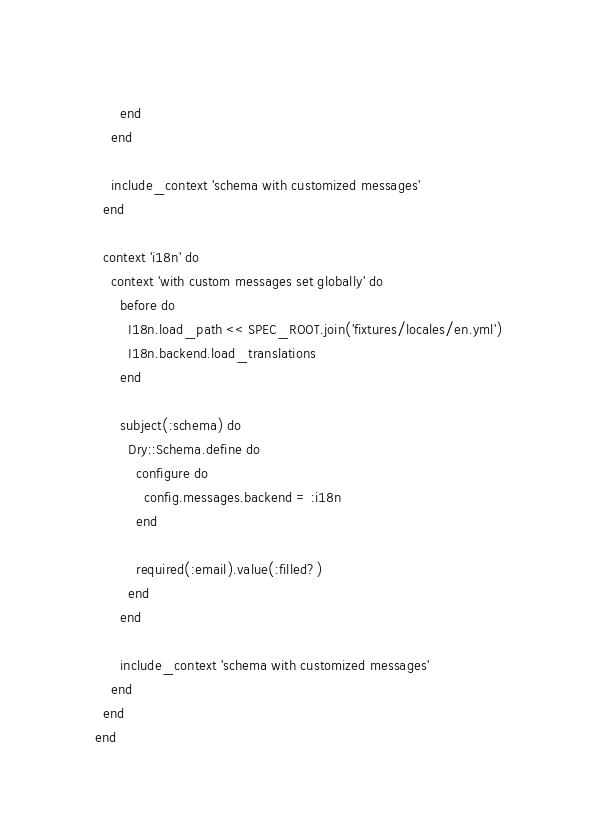<code> <loc_0><loc_0><loc_500><loc_500><_Ruby_>      end
    end

    include_context 'schema with customized messages'
  end

  context 'i18n' do
    context 'with custom messages set globally' do
      before do
        I18n.load_path << SPEC_ROOT.join('fixtures/locales/en.yml')
        I18n.backend.load_translations
      end

      subject(:schema) do
        Dry::Schema.define do
          configure do
            config.messages.backend = :i18n
          end

          required(:email).value(:filled?)
        end
      end

      include_context 'schema with customized messages'
    end
  end
end
</code> 